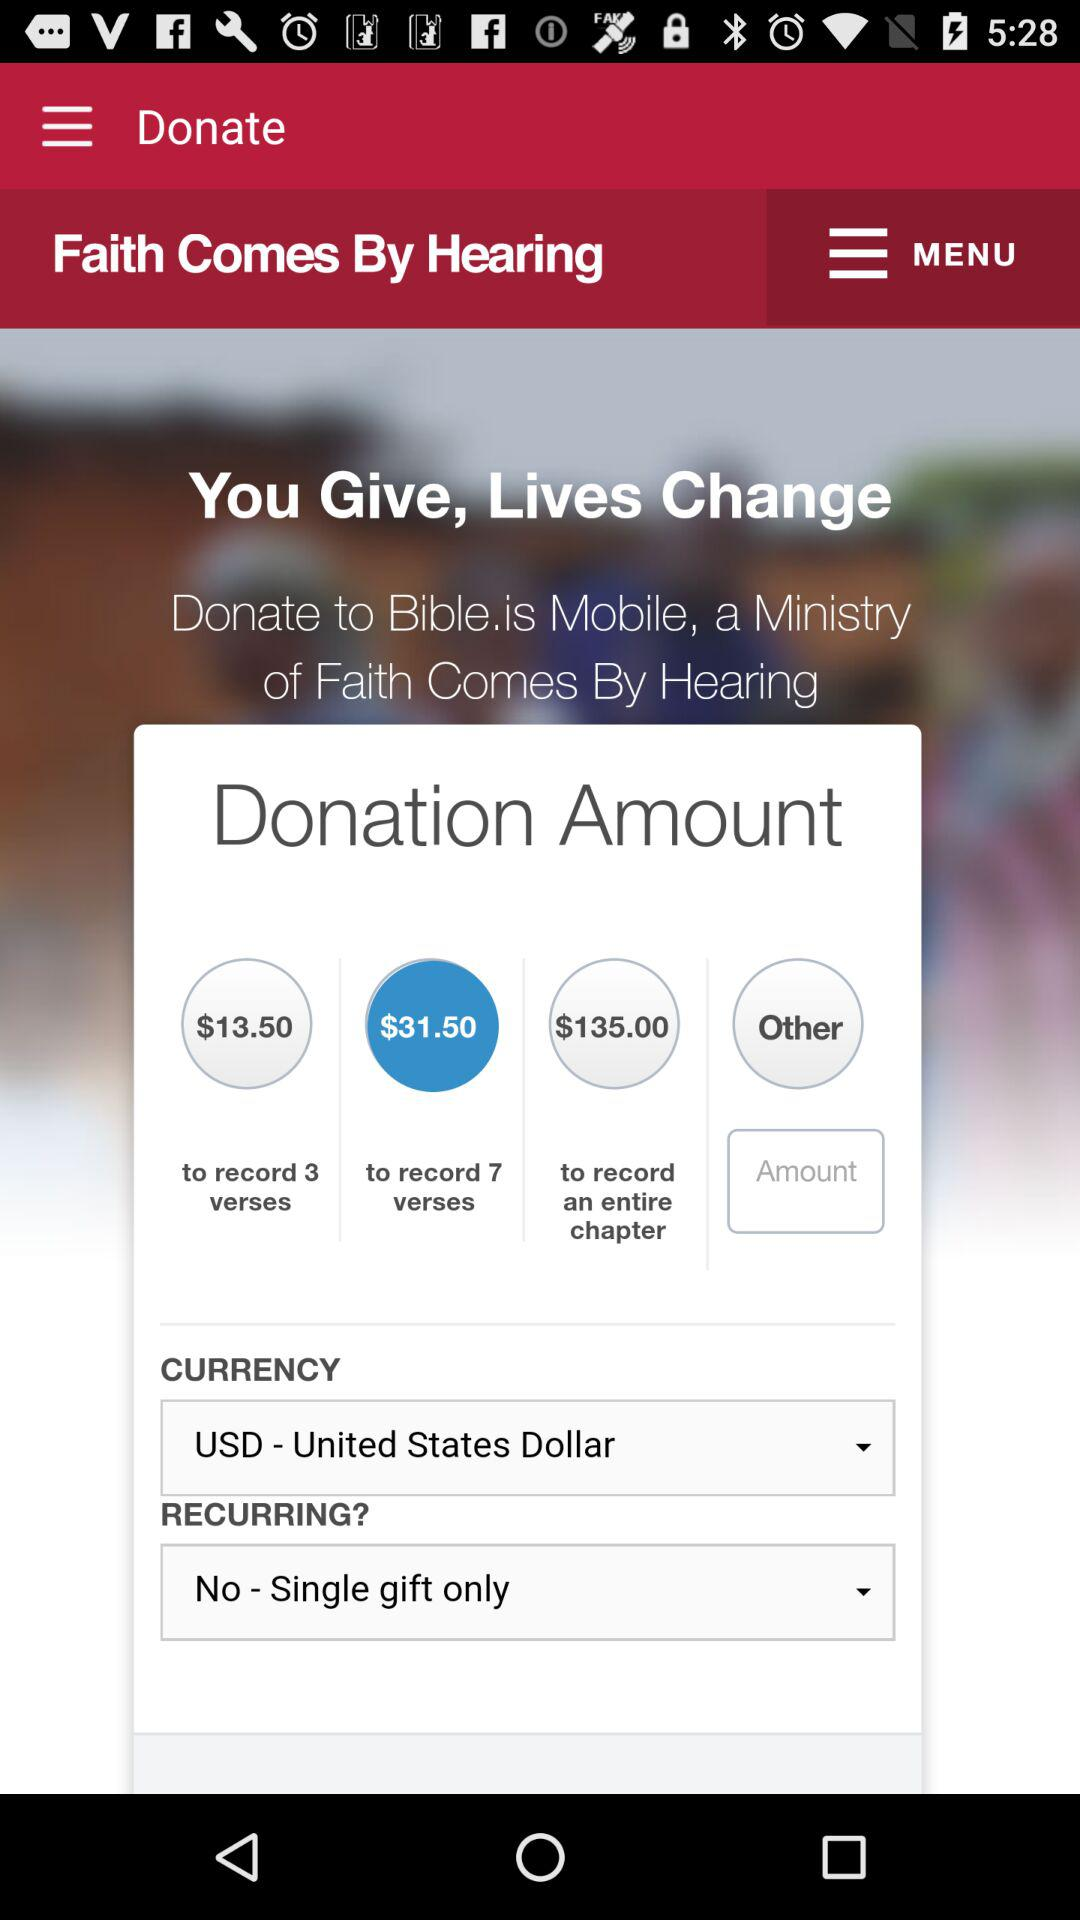What is the selected "RECURRING?"? The selected "RECURRING?" is "No - Single gift only". 